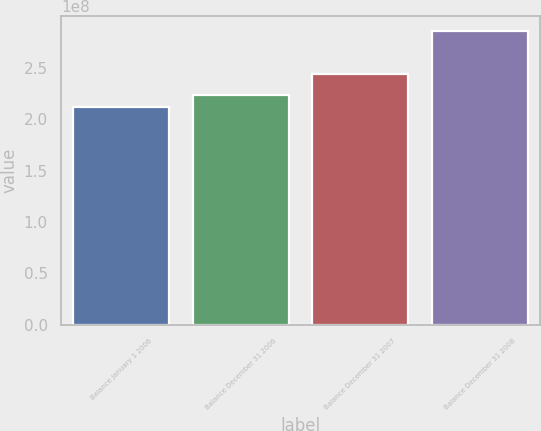Convert chart. <chart><loc_0><loc_0><loc_500><loc_500><bar_chart><fcel>Balance January 1 2006<fcel>Balance December 31 2006<fcel>Balance December 31 2007<fcel>Balance December 31 2008<nl><fcel>2.12091e+08<fcel>2.23522e+08<fcel>2.44217e+08<fcel>2.85662e+08<nl></chart> 